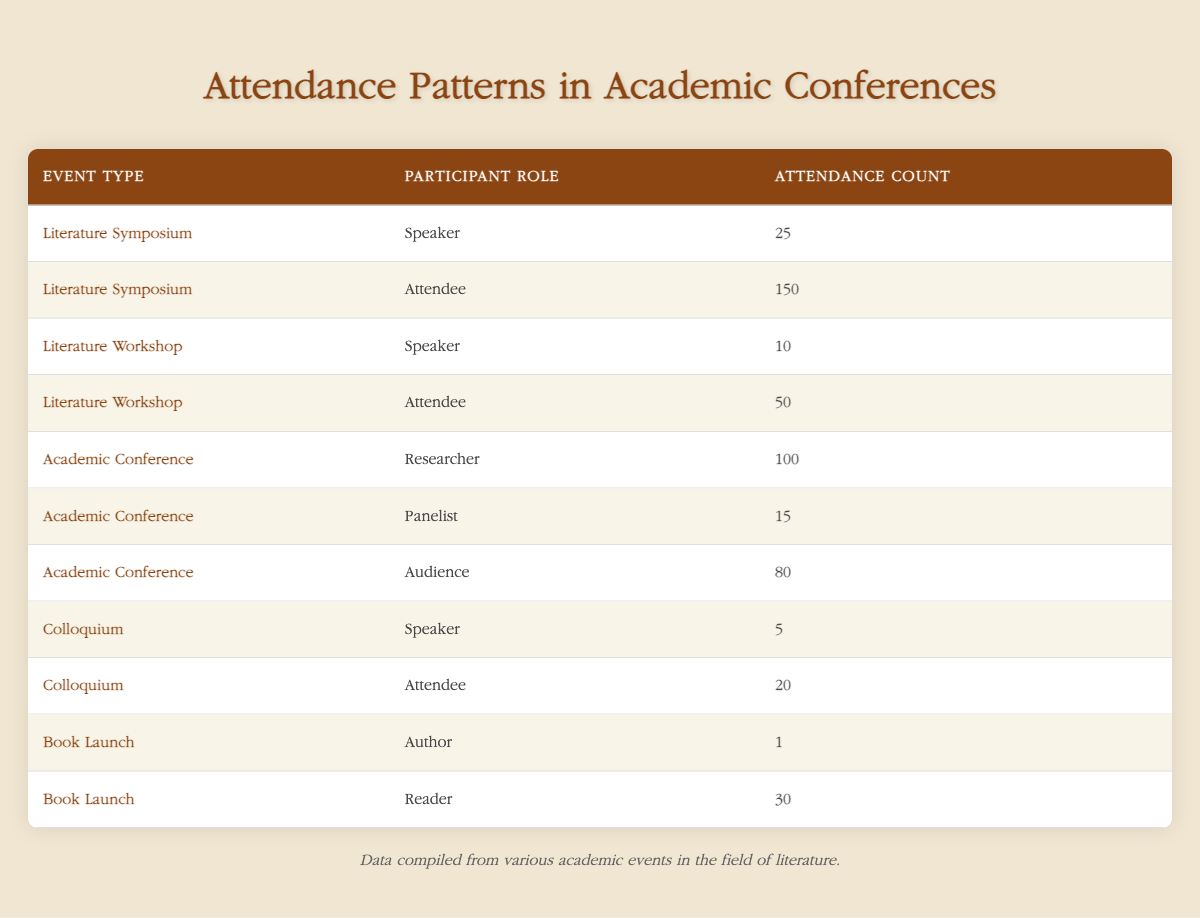What is the attendance count for the Literature Symposium Attendees? The table indicates that for the Literature Symposium, the role of Attendee has an attendance count of 150.
Answer: 150 How many total attendees were there at the Academic Conference, including Researchers, Panelists, and Audience? To find the total attendance count for the Academic Conference, we add the counts: 100 (Researcher) + 15 (Panelist) + 80 (Audience) = 195.
Answer: 195 Which event type had the highest attendance count and what was the number? The Literature Symposium has the highest attendance count for Attendees at 150.
Answer: 150 Is there any event type where the number of Speakers is greater than the number of Attendees? By examining the counts, we see that the Literature Workshop has more Attendees (50) compared to its Speakers (10), and similarly for all other events as well, indicating that there are no event types where Speakers exceed Attendees.
Answer: No What is the total attendance count for all roles in the Colloquium? For the Colloquium, we sum the counts: 5 (Speaker) + 20 (Attendee) = 25.
Answer: 25 How many more attendees were there in the Academic Conference than in the Literature Workshop? The Academic Conference has a total of 195 attendees (as calculated earlier), while the Literature Workshop has 50. The difference is 195 - 50 = 145.
Answer: 145 Is the attendance count for Readers at the Book Launch greater than the attendance count for Speakers at the Colloquium? The attendance for Readers is 30, while the Speakers at the Colloquium have 5. Since 30 is greater than 5, the statement is true.
Answer: Yes What was the average attendance count for all events in the table? To calculate the average, first, sum all attendance counts: 25 + 150 + 10 + 50 + 100 + 15 + 80 + 5 + 20 + 1 + 30 = 466. There are 11 events, so the average is 466 / 11 = 42.36 (rounded for simplicity).
Answer: 42.36 